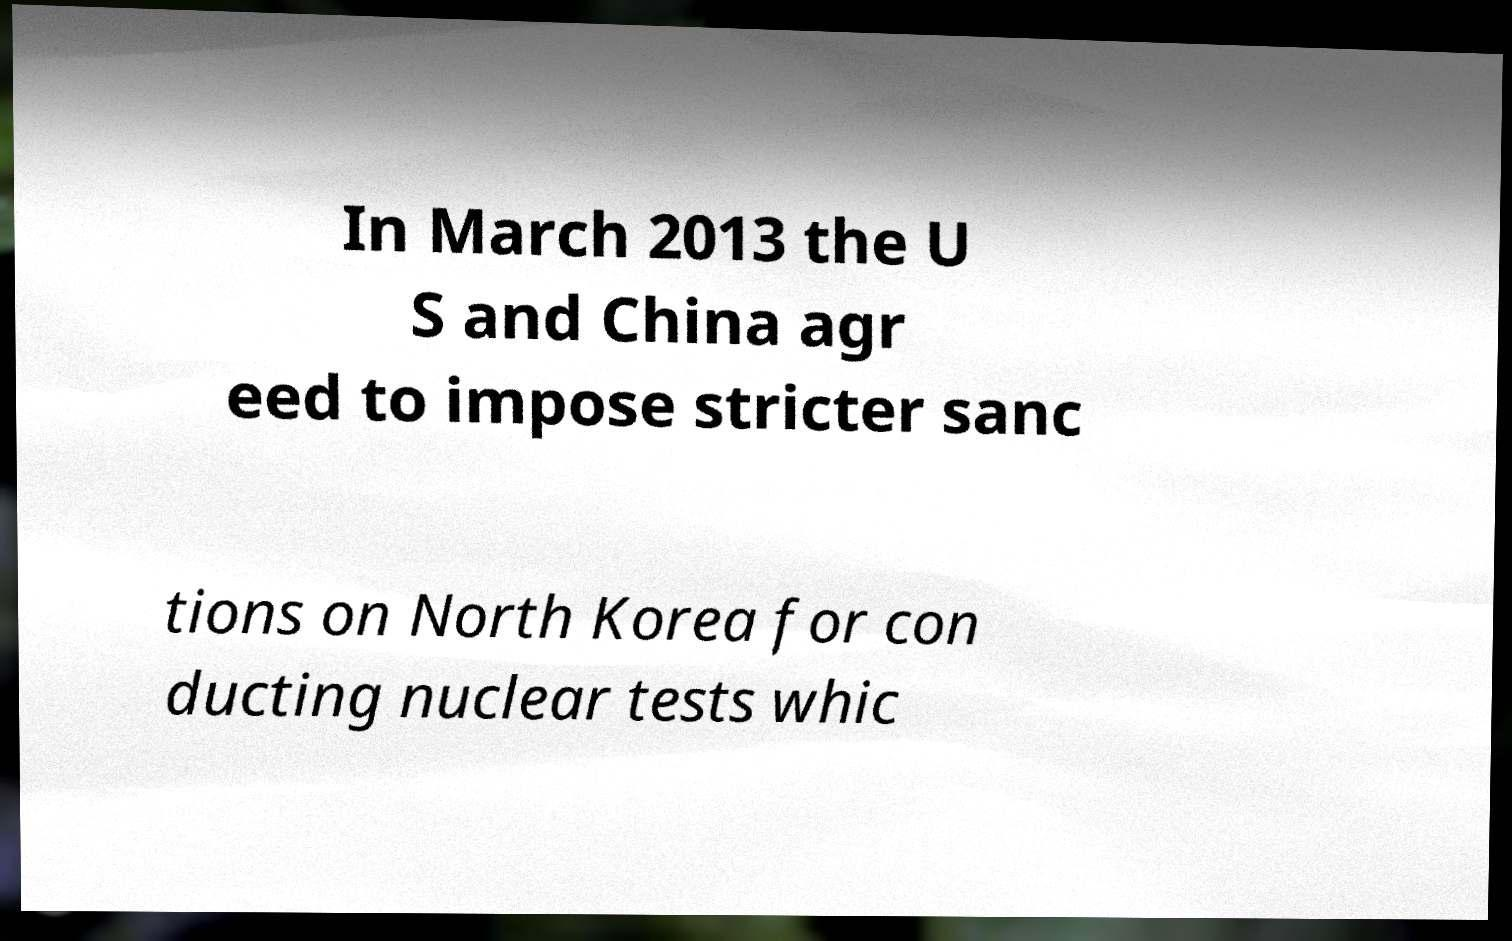There's text embedded in this image that I need extracted. Can you transcribe it verbatim? In March 2013 the U S and China agr eed to impose stricter sanc tions on North Korea for con ducting nuclear tests whic 